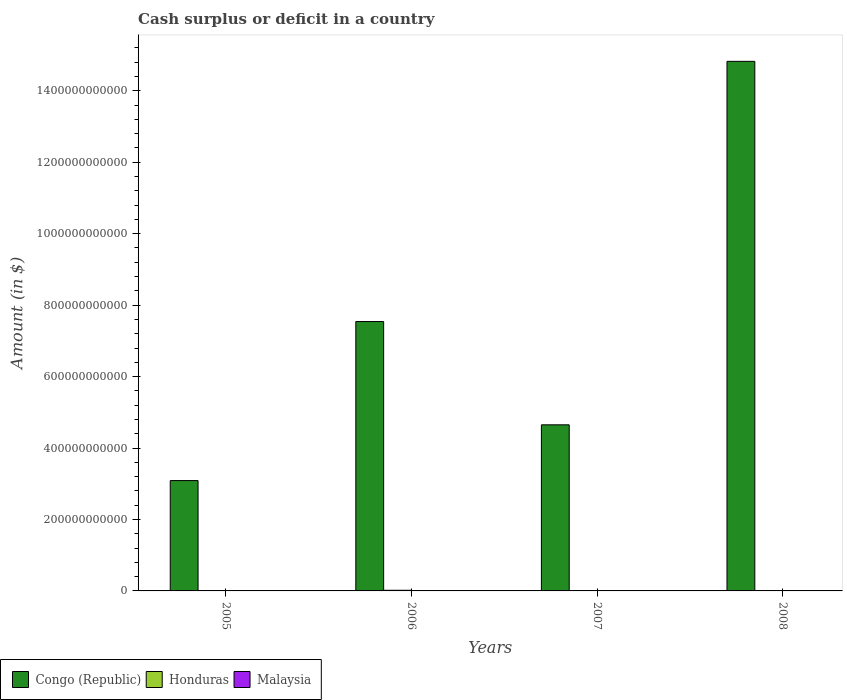How many different coloured bars are there?
Provide a succinct answer. 2. Are the number of bars per tick equal to the number of legend labels?
Your response must be concise. No. Are the number of bars on each tick of the X-axis equal?
Keep it short and to the point. No. What is the amount of cash surplus or deficit in Honduras in 2006?
Make the answer very short. 1.80e+09. Across all years, what is the maximum amount of cash surplus or deficit in Honduras?
Keep it short and to the point. 1.80e+09. Across all years, what is the minimum amount of cash surplus or deficit in Malaysia?
Keep it short and to the point. 0. What is the total amount of cash surplus or deficit in Congo (Republic) in the graph?
Your answer should be very brief. 3.01e+12. What is the difference between the amount of cash surplus or deficit in Congo (Republic) in 2006 and that in 2008?
Offer a very short reply. -7.28e+11. What is the average amount of cash surplus or deficit in Honduras per year?
Ensure brevity in your answer.  4.50e+08. In the year 2006, what is the difference between the amount of cash surplus or deficit in Honduras and amount of cash surplus or deficit in Congo (Republic)?
Provide a short and direct response. -7.52e+11. In how many years, is the amount of cash surplus or deficit in Congo (Republic) greater than 440000000000 $?
Make the answer very short. 3. What is the ratio of the amount of cash surplus or deficit in Congo (Republic) in 2006 to that in 2008?
Provide a succinct answer. 0.51. Is the amount of cash surplus or deficit in Congo (Republic) in 2005 less than that in 2008?
Give a very brief answer. Yes. What is the difference between the highest and the second highest amount of cash surplus or deficit in Congo (Republic)?
Give a very brief answer. 7.28e+11. What is the difference between the highest and the lowest amount of cash surplus or deficit in Congo (Republic)?
Keep it short and to the point. 1.17e+12. In how many years, is the amount of cash surplus or deficit in Honduras greater than the average amount of cash surplus or deficit in Honduras taken over all years?
Offer a very short reply. 1. Is it the case that in every year, the sum of the amount of cash surplus or deficit in Malaysia and amount of cash surplus or deficit in Honduras is greater than the amount of cash surplus or deficit in Congo (Republic)?
Your answer should be very brief. No. How many bars are there?
Your response must be concise. 5. What is the difference between two consecutive major ticks on the Y-axis?
Offer a terse response. 2.00e+11. Are the values on the major ticks of Y-axis written in scientific E-notation?
Provide a succinct answer. No. Does the graph contain any zero values?
Your answer should be very brief. Yes. Where does the legend appear in the graph?
Offer a very short reply. Bottom left. How many legend labels are there?
Your response must be concise. 3. What is the title of the graph?
Offer a terse response. Cash surplus or deficit in a country. What is the label or title of the X-axis?
Provide a succinct answer. Years. What is the label or title of the Y-axis?
Keep it short and to the point. Amount (in $). What is the Amount (in $) in Congo (Republic) in 2005?
Give a very brief answer. 3.09e+11. What is the Amount (in $) in Honduras in 2005?
Your response must be concise. 0. What is the Amount (in $) in Congo (Republic) in 2006?
Offer a very short reply. 7.54e+11. What is the Amount (in $) in Honduras in 2006?
Keep it short and to the point. 1.80e+09. What is the Amount (in $) in Congo (Republic) in 2007?
Your answer should be compact. 4.65e+11. What is the Amount (in $) in Congo (Republic) in 2008?
Offer a terse response. 1.48e+12. What is the Amount (in $) of Honduras in 2008?
Your answer should be very brief. 0. What is the Amount (in $) in Malaysia in 2008?
Offer a very short reply. 0. Across all years, what is the maximum Amount (in $) of Congo (Republic)?
Offer a very short reply. 1.48e+12. Across all years, what is the maximum Amount (in $) of Honduras?
Offer a very short reply. 1.80e+09. Across all years, what is the minimum Amount (in $) in Congo (Republic)?
Provide a short and direct response. 3.09e+11. What is the total Amount (in $) of Congo (Republic) in the graph?
Offer a terse response. 3.01e+12. What is the total Amount (in $) in Honduras in the graph?
Offer a terse response. 1.80e+09. What is the difference between the Amount (in $) in Congo (Republic) in 2005 and that in 2006?
Offer a terse response. -4.45e+11. What is the difference between the Amount (in $) of Congo (Republic) in 2005 and that in 2007?
Offer a very short reply. -1.56e+11. What is the difference between the Amount (in $) of Congo (Republic) in 2005 and that in 2008?
Give a very brief answer. -1.17e+12. What is the difference between the Amount (in $) of Congo (Republic) in 2006 and that in 2007?
Provide a succinct answer. 2.89e+11. What is the difference between the Amount (in $) in Congo (Republic) in 2006 and that in 2008?
Give a very brief answer. -7.28e+11. What is the difference between the Amount (in $) of Congo (Republic) in 2007 and that in 2008?
Offer a very short reply. -1.02e+12. What is the difference between the Amount (in $) of Congo (Republic) in 2005 and the Amount (in $) of Honduras in 2006?
Ensure brevity in your answer.  3.07e+11. What is the average Amount (in $) of Congo (Republic) per year?
Your answer should be very brief. 7.53e+11. What is the average Amount (in $) in Honduras per year?
Your answer should be very brief. 4.50e+08. What is the average Amount (in $) in Malaysia per year?
Your answer should be very brief. 0. In the year 2006, what is the difference between the Amount (in $) in Congo (Republic) and Amount (in $) in Honduras?
Keep it short and to the point. 7.52e+11. What is the ratio of the Amount (in $) in Congo (Republic) in 2005 to that in 2006?
Provide a succinct answer. 0.41. What is the ratio of the Amount (in $) of Congo (Republic) in 2005 to that in 2007?
Offer a very short reply. 0.66. What is the ratio of the Amount (in $) of Congo (Republic) in 2005 to that in 2008?
Give a very brief answer. 0.21. What is the ratio of the Amount (in $) in Congo (Republic) in 2006 to that in 2007?
Offer a terse response. 1.62. What is the ratio of the Amount (in $) in Congo (Republic) in 2006 to that in 2008?
Keep it short and to the point. 0.51. What is the ratio of the Amount (in $) in Congo (Republic) in 2007 to that in 2008?
Offer a terse response. 0.31. What is the difference between the highest and the second highest Amount (in $) in Congo (Republic)?
Provide a short and direct response. 7.28e+11. What is the difference between the highest and the lowest Amount (in $) of Congo (Republic)?
Your answer should be very brief. 1.17e+12. What is the difference between the highest and the lowest Amount (in $) of Honduras?
Offer a very short reply. 1.80e+09. 